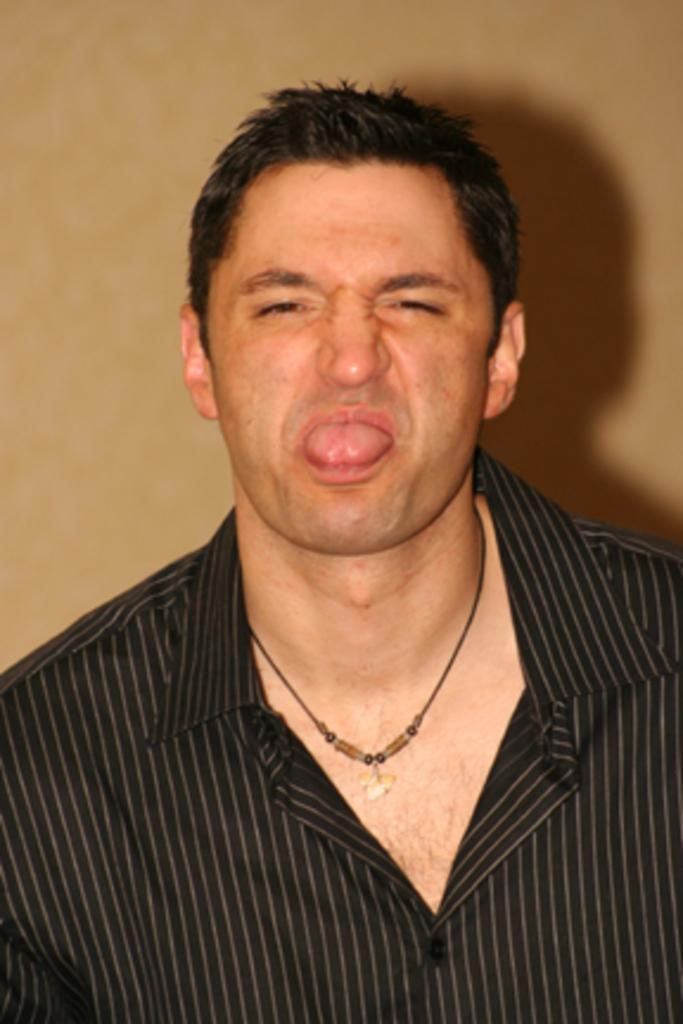What is present in the image? There is a person in the image. What is the person wearing? The person is wearing a shirt. What can be seen in the background of the image? There is a wall in the background of the image. What type of writing can be seen on the wall in the image? There is no writing visible on the wall in the image. What is the condition of the horse in the image? There is no horse present in the image. 